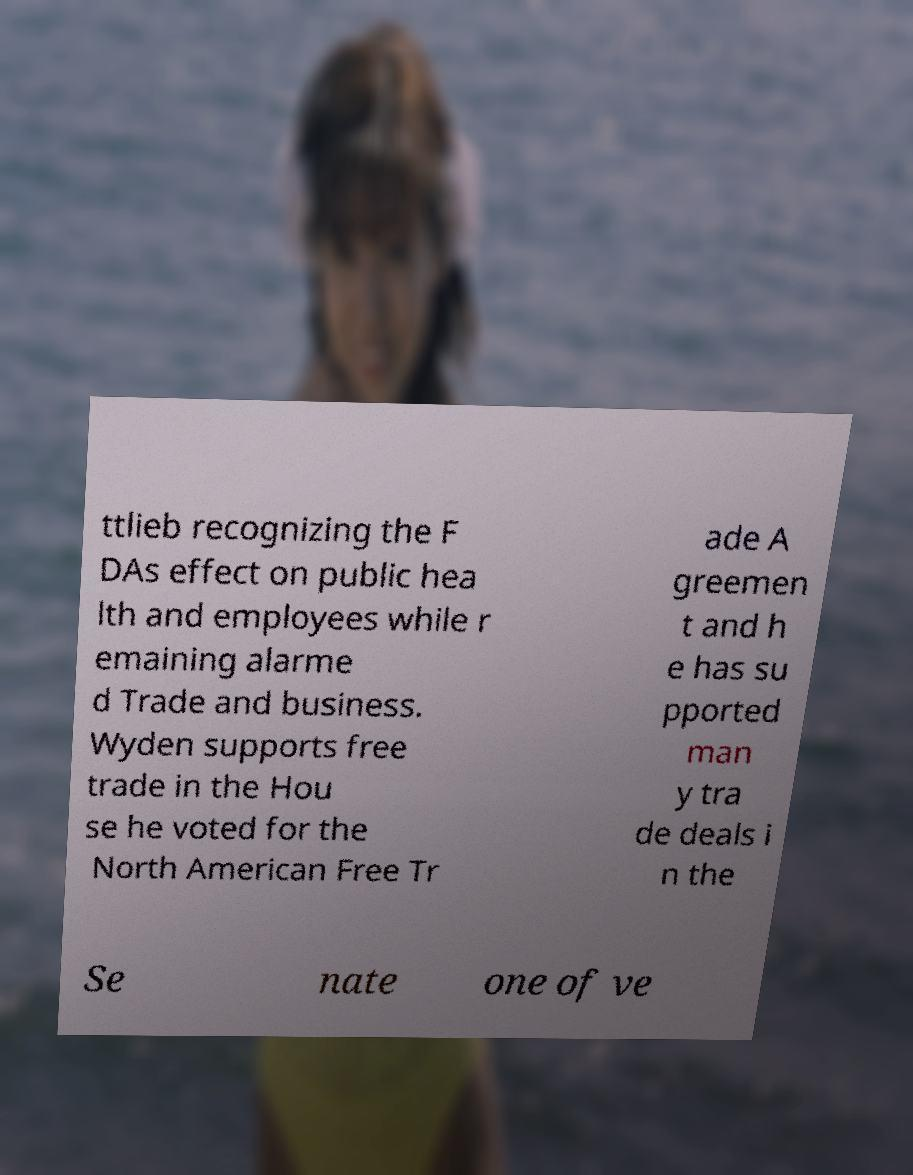Please read and relay the text visible in this image. What does it say? ttlieb recognizing the F DAs effect on public hea lth and employees while r emaining alarme d Trade and business. Wyden supports free trade in the Hou se he voted for the North American Free Tr ade A greemen t and h e has su pported man y tra de deals i n the Se nate one of ve 